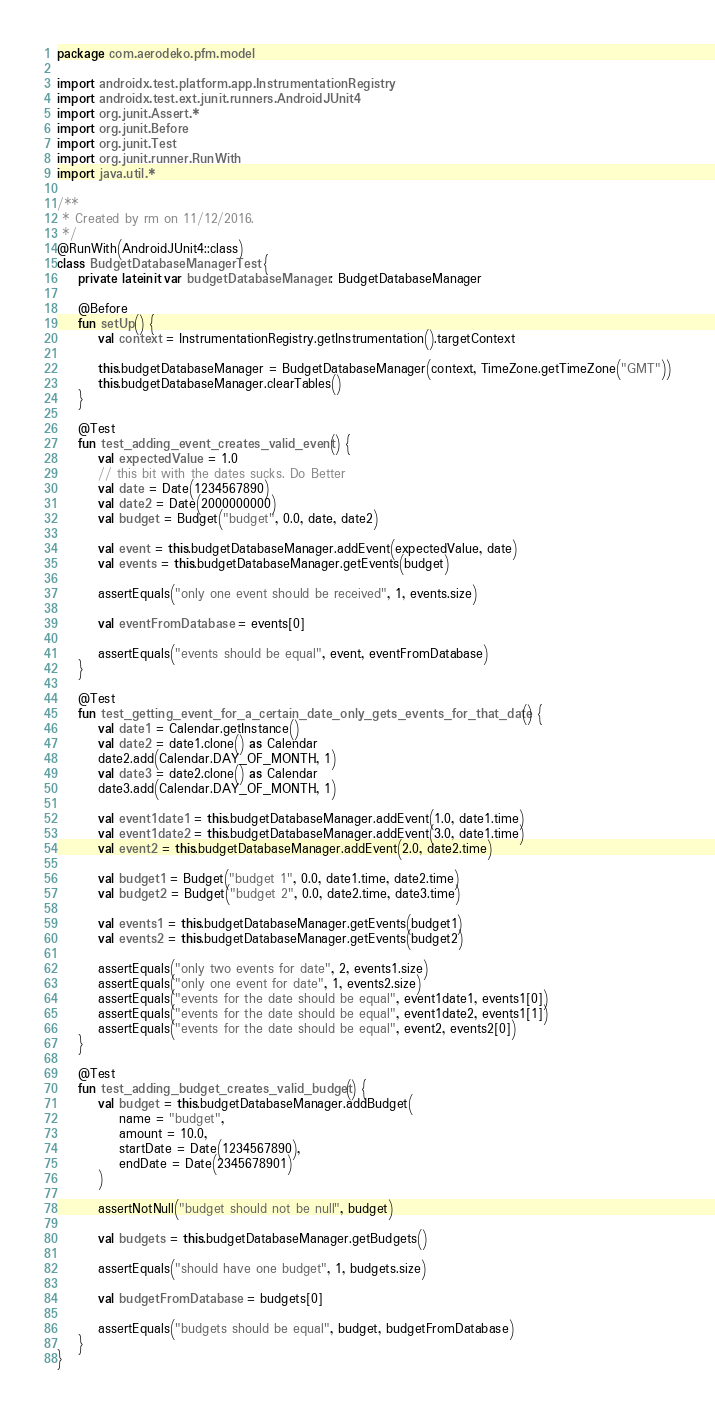Convert code to text. <code><loc_0><loc_0><loc_500><loc_500><_Kotlin_>package com.aerodeko.pfm.model

import androidx.test.platform.app.InstrumentationRegistry
import androidx.test.ext.junit.runners.AndroidJUnit4
import org.junit.Assert.*
import org.junit.Before
import org.junit.Test
import org.junit.runner.RunWith
import java.util.*

/**
 * Created by rm on 11/12/2016.
 */
@RunWith(AndroidJUnit4::class)
class BudgetDatabaseManagerTest {
    private lateinit var budgetDatabaseManager: BudgetDatabaseManager

    @Before
    fun setUp() {
        val context = InstrumentationRegistry.getInstrumentation().targetContext

        this.budgetDatabaseManager = BudgetDatabaseManager(context, TimeZone.getTimeZone("GMT"))
        this.budgetDatabaseManager.clearTables()
    }

    @Test
    fun test_adding_event_creates_valid_event() {
        val expectedValue = 1.0
        // this bit with the dates sucks. Do Better
        val date = Date(1234567890)
        val date2 = Date(2000000000)
        val budget = Budget("budget", 0.0, date, date2)

        val event = this.budgetDatabaseManager.addEvent(expectedValue, date)
        val events = this.budgetDatabaseManager.getEvents(budget)

        assertEquals("only one event should be received", 1, events.size)

        val eventFromDatabase = events[0]

        assertEquals("events should be equal", event, eventFromDatabase)
    }

    @Test
    fun test_getting_event_for_a_certain_date_only_gets_events_for_that_date() {
        val date1 = Calendar.getInstance()
        val date2 = date1.clone() as Calendar
        date2.add(Calendar.DAY_OF_MONTH, 1)
        val date3 = date2.clone() as Calendar
        date3.add(Calendar.DAY_OF_MONTH, 1)

        val event1date1 = this.budgetDatabaseManager.addEvent(1.0, date1.time)
        val event1date2 = this.budgetDatabaseManager.addEvent(3.0, date1.time)
        val event2 = this.budgetDatabaseManager.addEvent(2.0, date2.time)

        val budget1 = Budget("budget 1", 0.0, date1.time, date2.time)
        val budget2 = Budget("budget 2", 0.0, date2.time, date3.time)

        val events1 = this.budgetDatabaseManager.getEvents(budget1)
        val events2 = this.budgetDatabaseManager.getEvents(budget2)

        assertEquals("only two events for date", 2, events1.size)
        assertEquals("only one event for date", 1, events2.size)
        assertEquals("events for the date should be equal", event1date1, events1[0])
        assertEquals("events for the date should be equal", event1date2, events1[1])
        assertEquals("events for the date should be equal", event2, events2[0])
    }

    @Test
    fun test_adding_budget_creates_valid_budget() {
        val budget = this.budgetDatabaseManager.addBudget(
            name = "budget",
            amount = 10.0,
            startDate = Date(1234567890),
            endDate = Date(2345678901)
        )

        assertNotNull("budget should not be null", budget)

        val budgets = this.budgetDatabaseManager.getBudgets()

        assertEquals("should have one budget", 1, budgets.size)

        val budgetFromDatabase = budgets[0]

        assertEquals("budgets should be equal", budget, budgetFromDatabase)
    }
}
</code> 